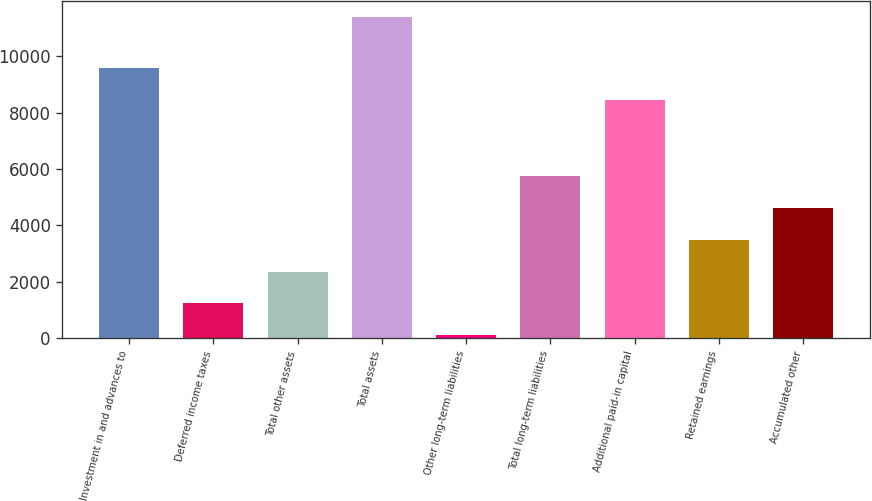Convert chart. <chart><loc_0><loc_0><loc_500><loc_500><bar_chart><fcel>Investment in and advances to<fcel>Deferred income taxes<fcel>Total other assets<fcel>Total assets<fcel>Other long-term liabilities<fcel>Total long-term liabilities<fcel>Additional paid-in capital<fcel>Retained earnings<fcel>Accumulated other<nl><fcel>9571.3<fcel>1234.3<fcel>2361.6<fcel>11380<fcel>107<fcel>5743.5<fcel>8444<fcel>3488.9<fcel>4616.2<nl></chart> 